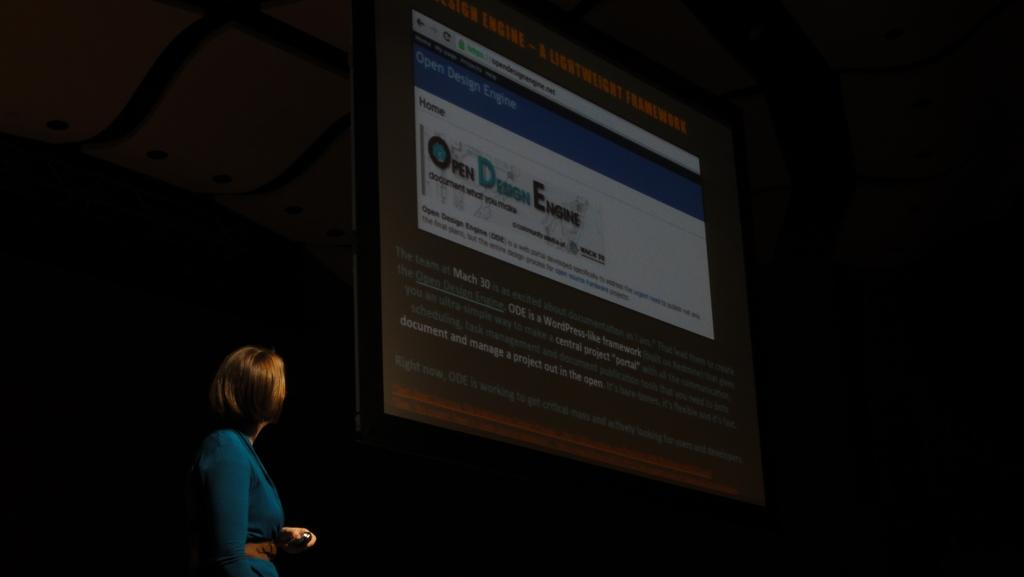Who is the main subject in the image? There is a lady in the image. What is the lady wearing? The lady is wearing a green dress. What can be seen behind the lady in the image? The lady is standing beside a projector screen. What type of company does the squirrel represent in the image? There is no squirrel present in the image, so it cannot represent any company. 